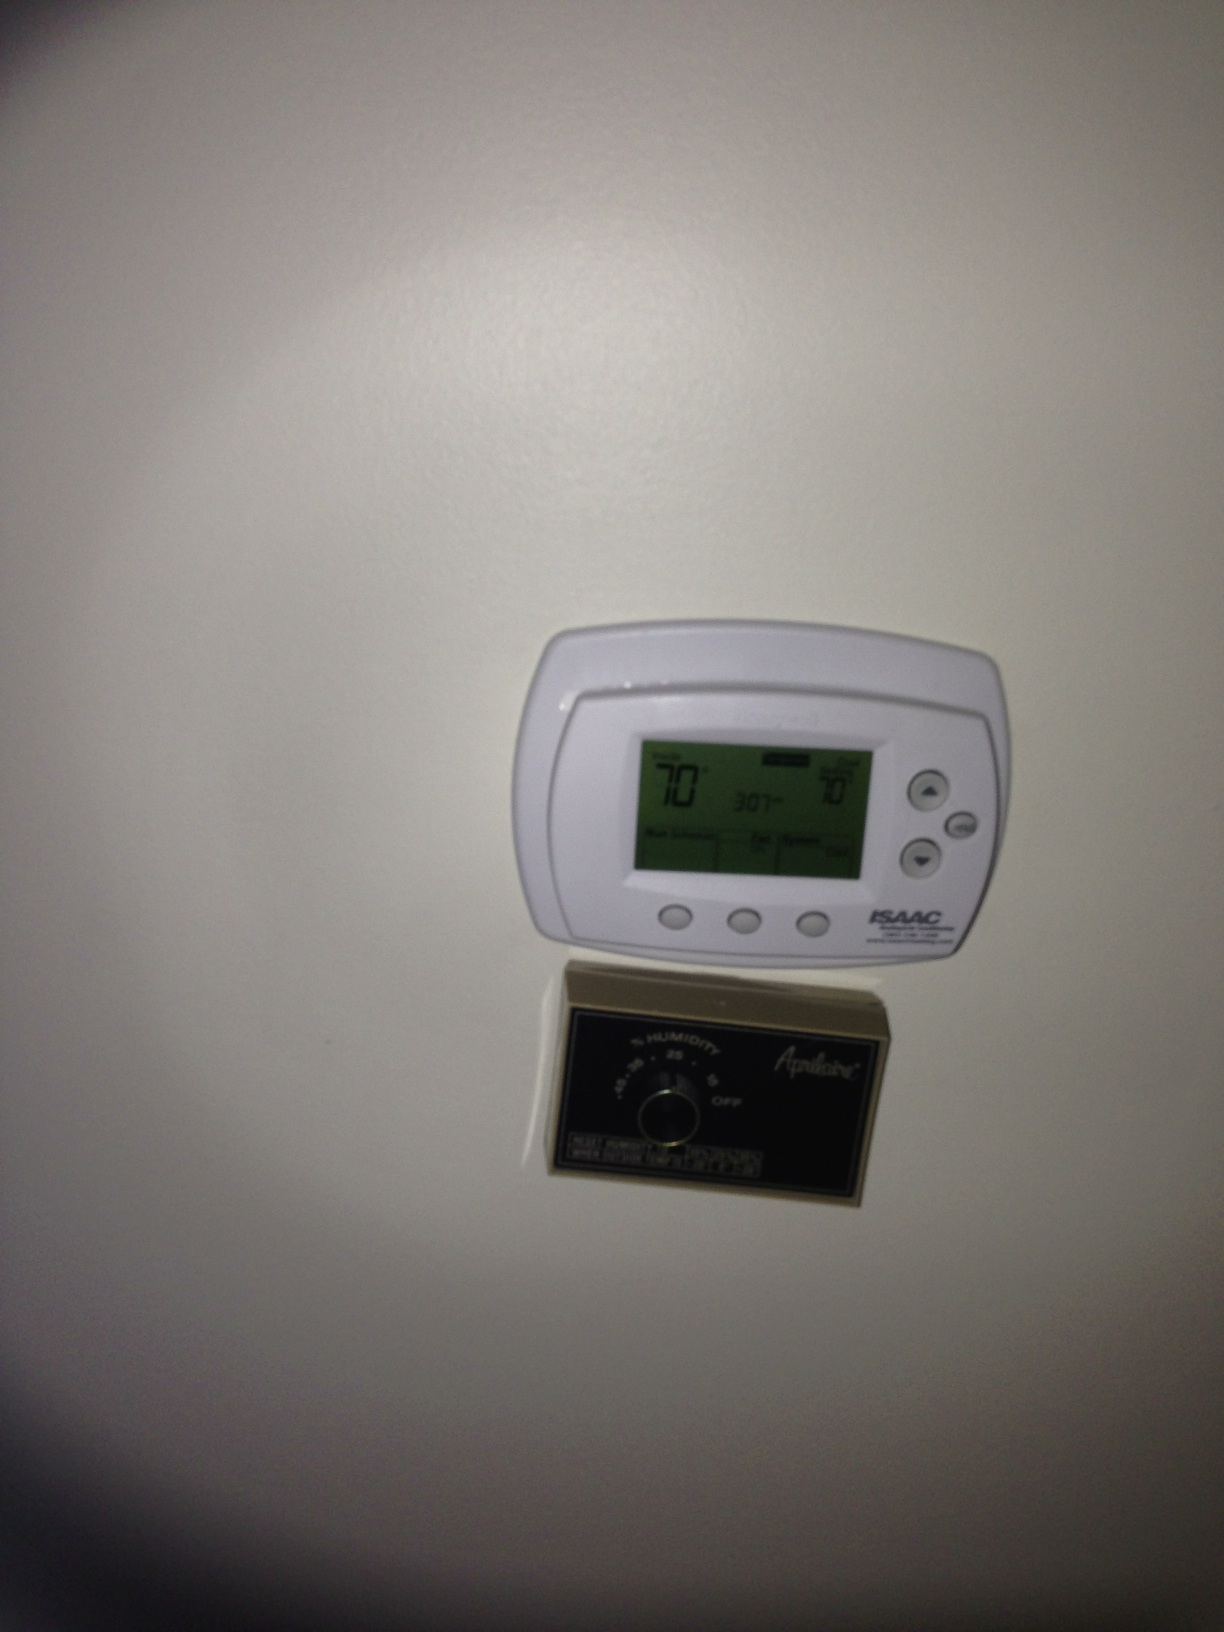What settings can be controlled using the thermometer panel? The thermometer panel allows you to control various settings. From left to right, the buttons typically adjust the fan setting (On/Auto), the system mode (Heat/Cool), and the temperature settings (Increase/Decrease). This provides comprehensive control over your home’s heating and cooling system, making it more comfortable and efficient. Can you explain the purpose of the additional control panel located beneath the thermometer? Certainly! The control panel beneath the thermometer appears to be a humidity controller, likely for a humidifier. It allows you to set the desired humidity level in your home. Maintaining optimal humidity levels can enhance comfort, protect wooden furniture and instruments, and contribute to better indoor air quality. How does adjusting the humidity level affect the overall comfort in a home? Adjusting the humidity level can significantly impact comfort. In dry conditions, increasing humidity can alleviate dry skin, irritation, and respiratory issues. Conversely, in humid conditions, reducing humidity can prevent mold growth and make the air feel cooler and more comfortable. Optimal indoor humidity levels typically range between 30% to 50%. 